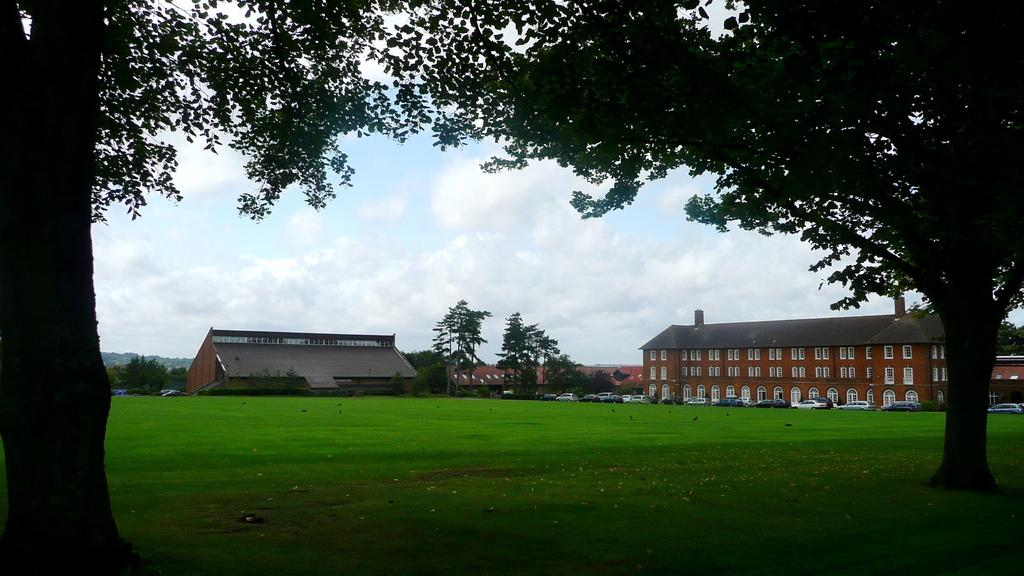What is the main element in the center of the image? There is sky in the center of the image. What can be seen in the sky? There are clouds in the image. What type of natural vegetation is present in the image? There are trees in the image. What type of man-made structures are visible in the image? There are buildings in the image. What part of the buildings can be seen in the image? There are windows in the image. What type of transportation is present in the image? There are vehicles in the image. What type of ground surface is visible in the image? There is grass in the image. How many birds are perched on the hands in the image? There are no birds or hands present in the image. 